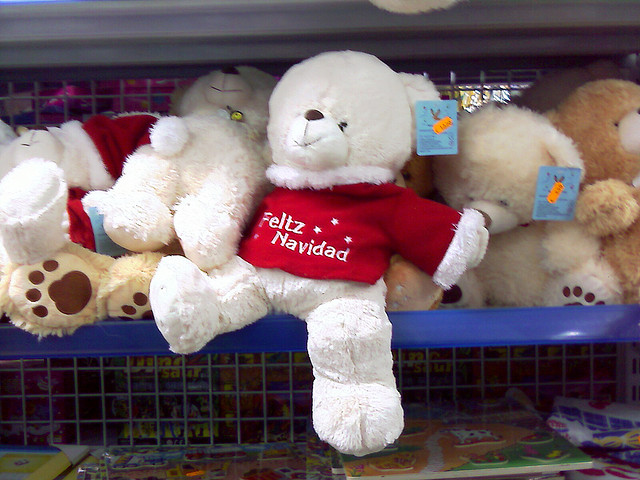Describe the teddy bear in the picture. The teddy bear in the image has white fur and seems to be soft and fluffy. It's wearing a bright red shirt with 'Feliz Navidad' printed on it, which suggests a festive, holiday theme. The bear is positioned prominently on a shelf among other toys, likely in a store setting given the price tags visible on other items. 